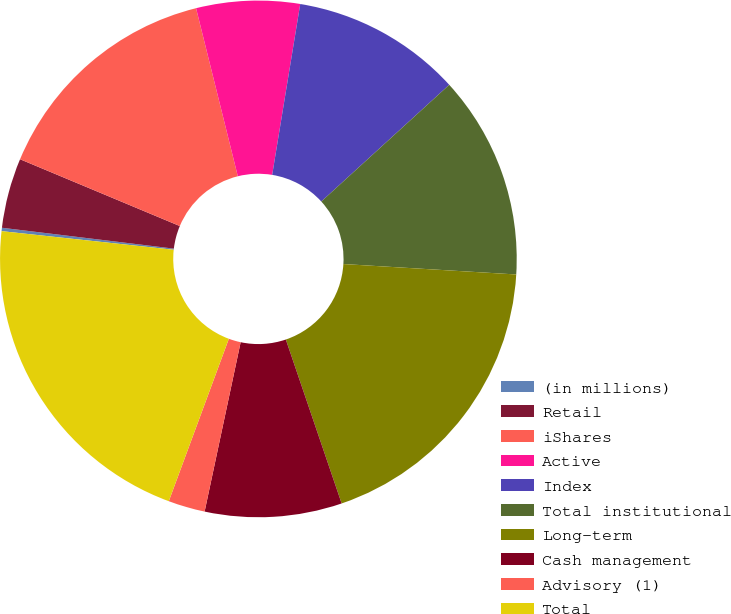Convert chart. <chart><loc_0><loc_0><loc_500><loc_500><pie_chart><fcel>(in millions)<fcel>Retail<fcel>iShares<fcel>Active<fcel>Index<fcel>Total institutional<fcel>Long-term<fcel>Cash management<fcel>Advisory (1)<fcel>Total<nl><fcel>0.21%<fcel>4.38%<fcel>14.82%<fcel>6.47%<fcel>10.64%<fcel>12.73%<fcel>18.82%<fcel>8.56%<fcel>2.3%<fcel>21.08%<nl></chart> 